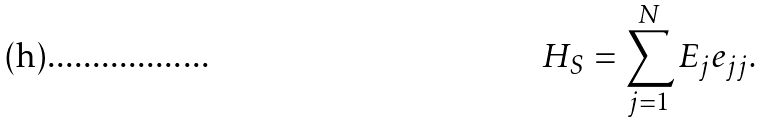Convert formula to latex. <formula><loc_0><loc_0><loc_500><loc_500>H _ { S } = \sum _ { j = 1 } ^ { N } E _ { j } e _ { j j } .</formula> 